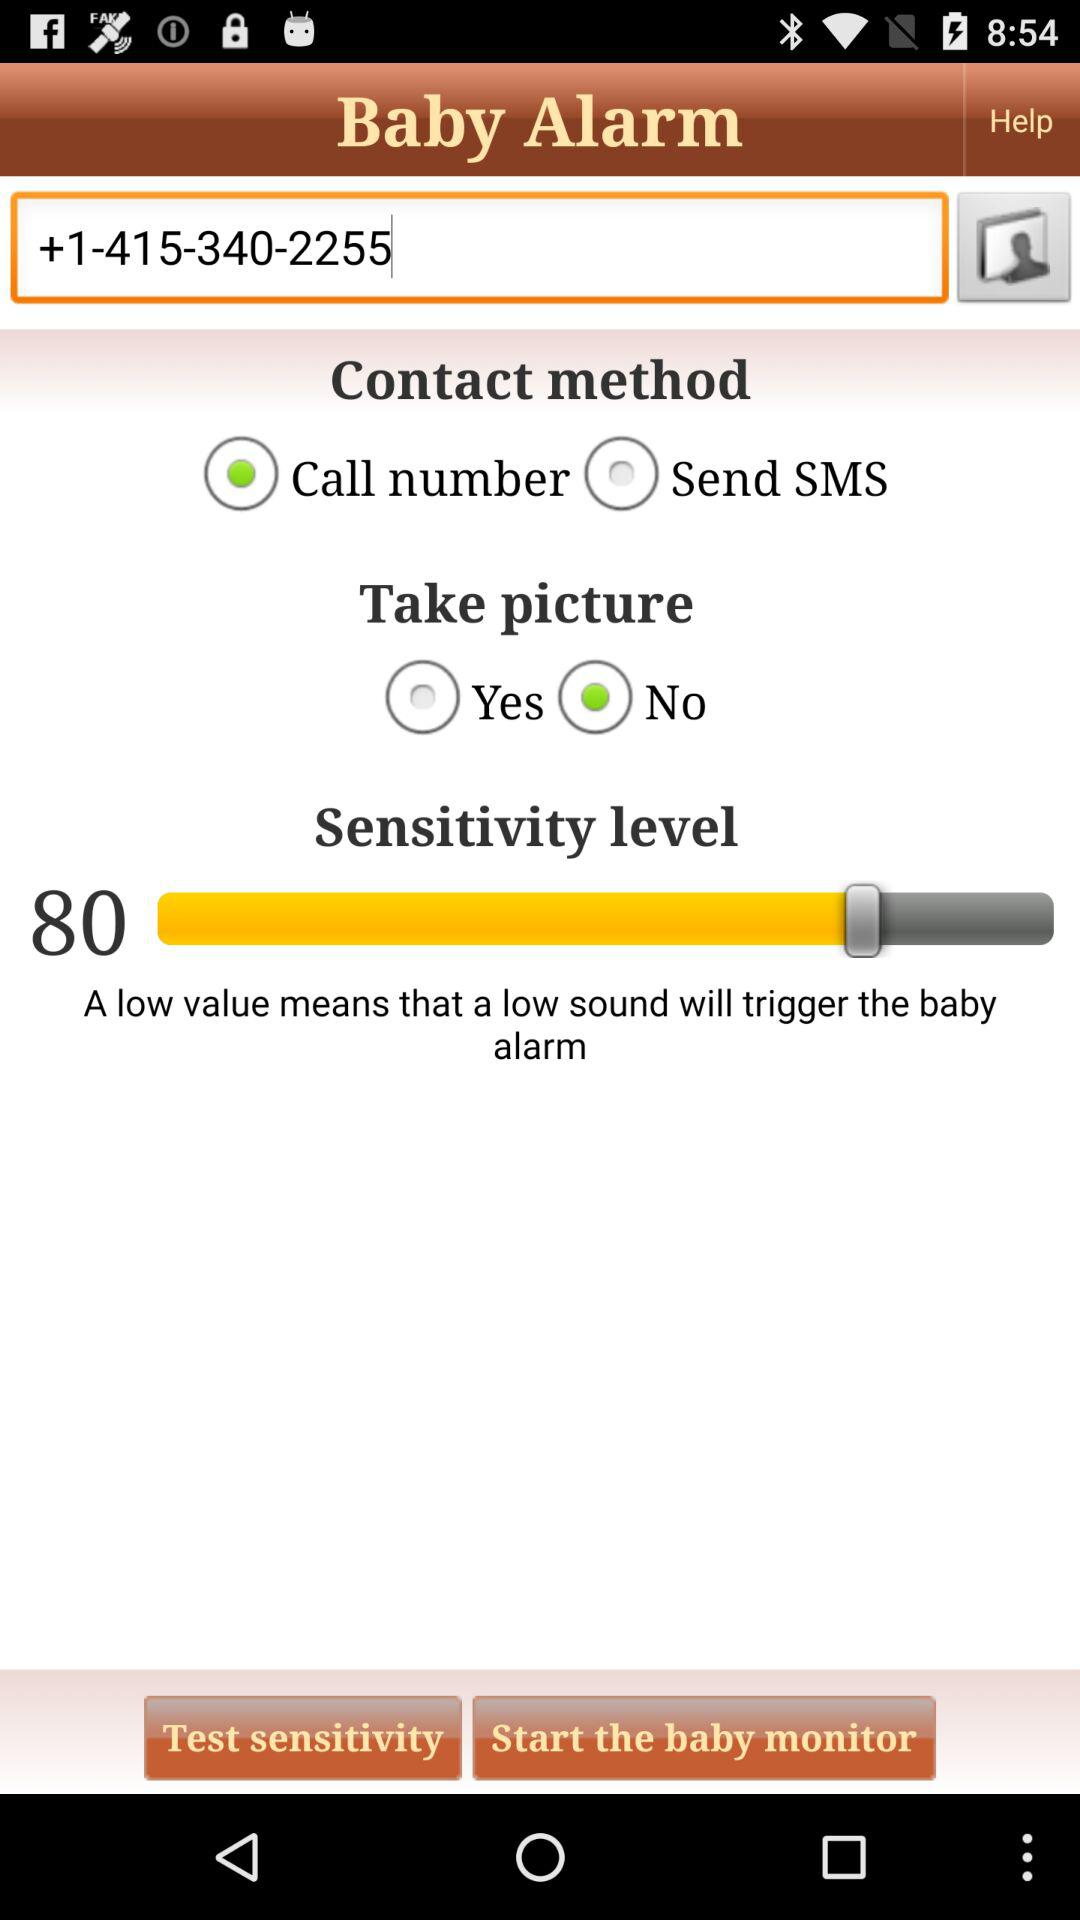Which option is selected in the "Take picture" option? The selected option is "No". 